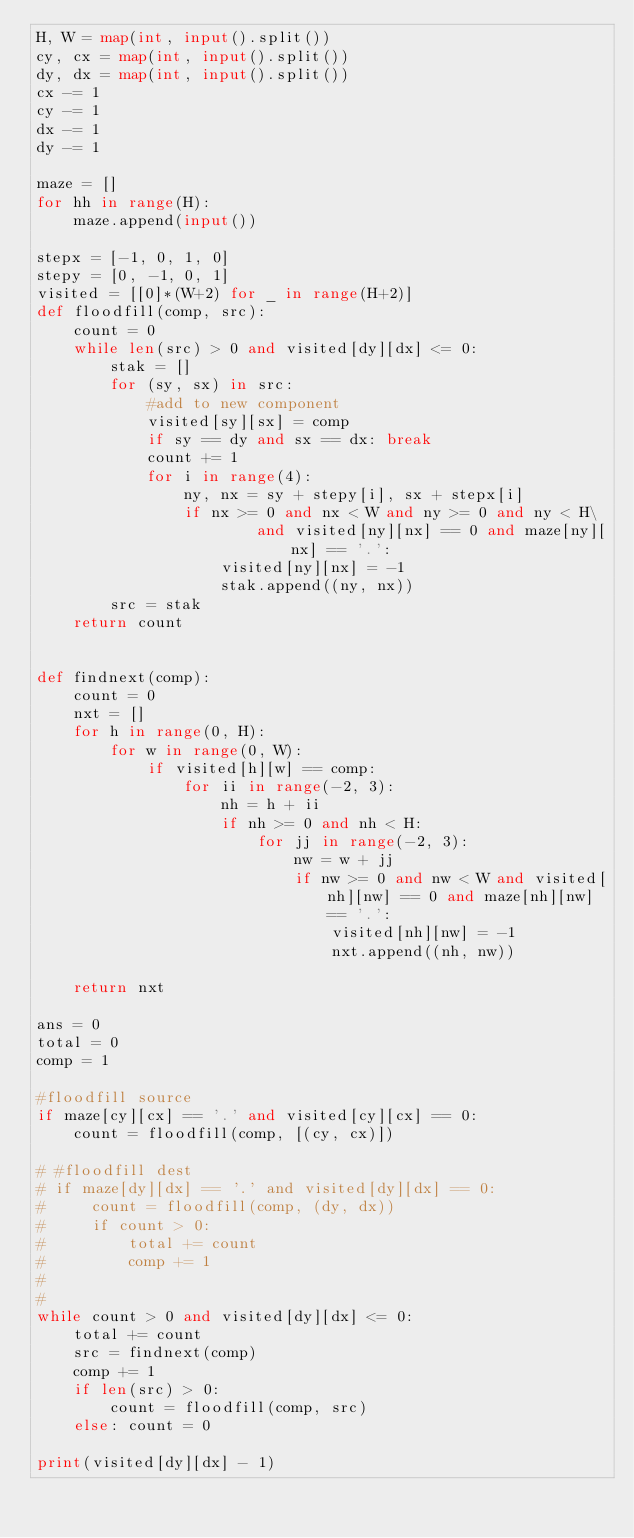<code> <loc_0><loc_0><loc_500><loc_500><_Python_>H, W = map(int, input().split())
cy, cx = map(int, input().split())
dy, dx = map(int, input().split())
cx -= 1
cy -= 1
dx -= 1
dy -= 1

maze = []
for hh in range(H):
    maze.append(input())

stepx = [-1, 0, 1, 0]
stepy = [0, -1, 0, 1]
visited = [[0]*(W+2) for _ in range(H+2)]
def floodfill(comp, src):
    count = 0
    while len(src) > 0 and visited[dy][dx] <= 0:
        stak = []
        for (sy, sx) in src:
            #add to new component
            visited[sy][sx] = comp
            if sy == dy and sx == dx: break
            count += 1
            for i in range(4):
                ny, nx = sy + stepy[i], sx + stepx[i]
                if nx >= 0 and nx < W and ny >= 0 and ny < H\
                        and visited[ny][nx] == 0 and maze[ny][nx] == '.':
                    visited[ny][nx] = -1
                    stak.append((ny, nx))
        src = stak
    return count


def findnext(comp):
    count = 0
    nxt = []
    for h in range(0, H):
        for w in range(0, W):
            if visited[h][w] == comp:
                for ii in range(-2, 3):
                    nh = h + ii
                    if nh >= 0 and nh < H:
                        for jj in range(-2, 3):
                            nw = w + jj
                            if nw >= 0 and nw < W and visited[nh][nw] == 0 and maze[nh][nw] == '.':
                                visited[nh][nw] = -1
                                nxt.append((nh, nw))

    return nxt

ans = 0
total = 0
comp = 1

#floodfill source
if maze[cy][cx] == '.' and visited[cy][cx] == 0:
    count = floodfill(comp, [(cy, cx)])

# #floodfill dest
# if maze[dy][dx] == '.' and visited[dy][dx] == 0:
#     count = floodfill(comp, (dy, dx))
#     if count > 0:
#         total += count
#         comp += 1
#
#
while count > 0 and visited[dy][dx] <= 0:
    total += count
    src = findnext(comp)
    comp += 1
    if len(src) > 0:
        count = floodfill(comp, src)
    else: count = 0

print(visited[dy][dx] - 1)
</code> 